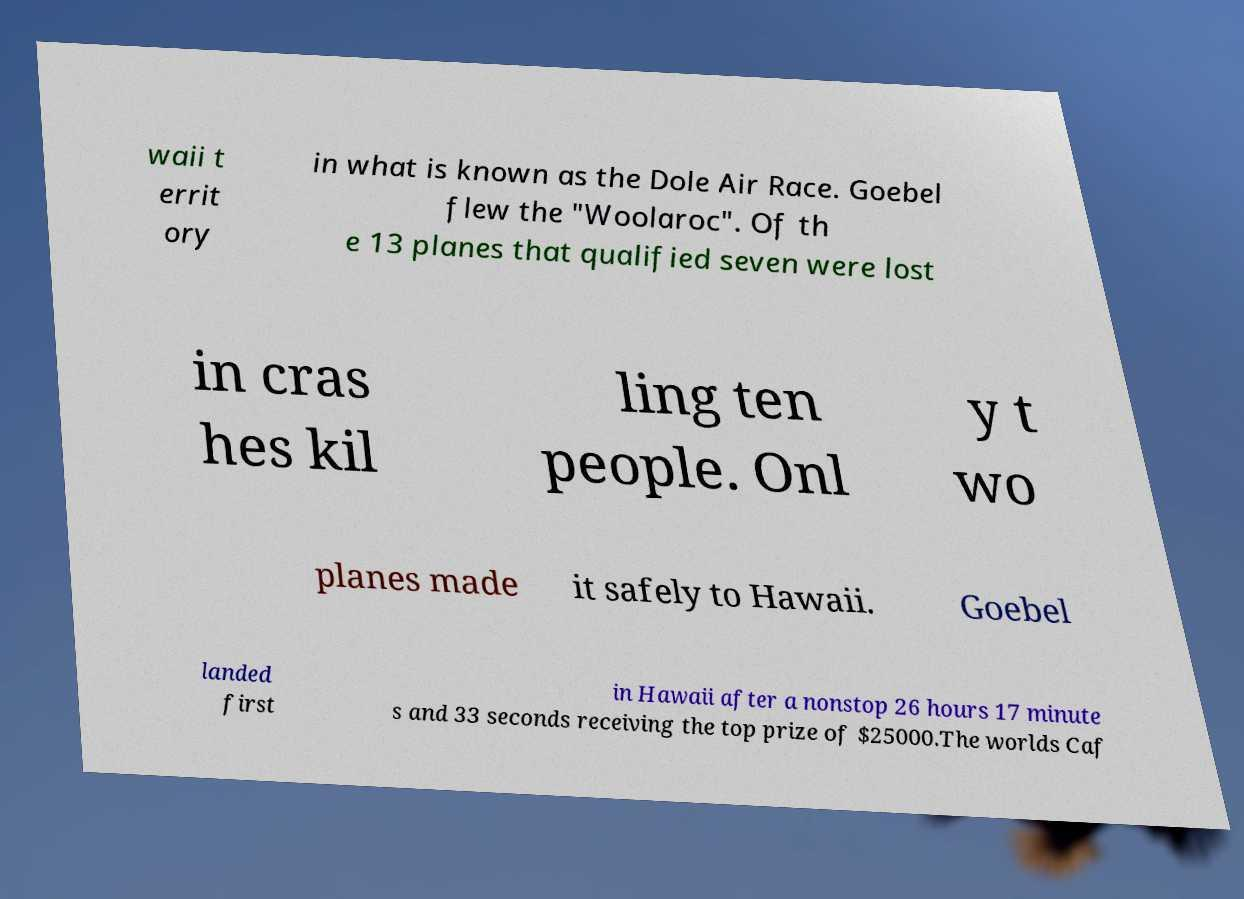Please read and relay the text visible in this image. What does it say? waii t errit ory in what is known as the Dole Air Race. Goebel flew the "Woolaroc". Of th e 13 planes that qualified seven were lost in cras hes kil ling ten people. Onl y t wo planes made it safely to Hawaii. Goebel landed first in Hawaii after a nonstop 26 hours 17 minute s and 33 seconds receiving the top prize of $25000.The worlds Caf 